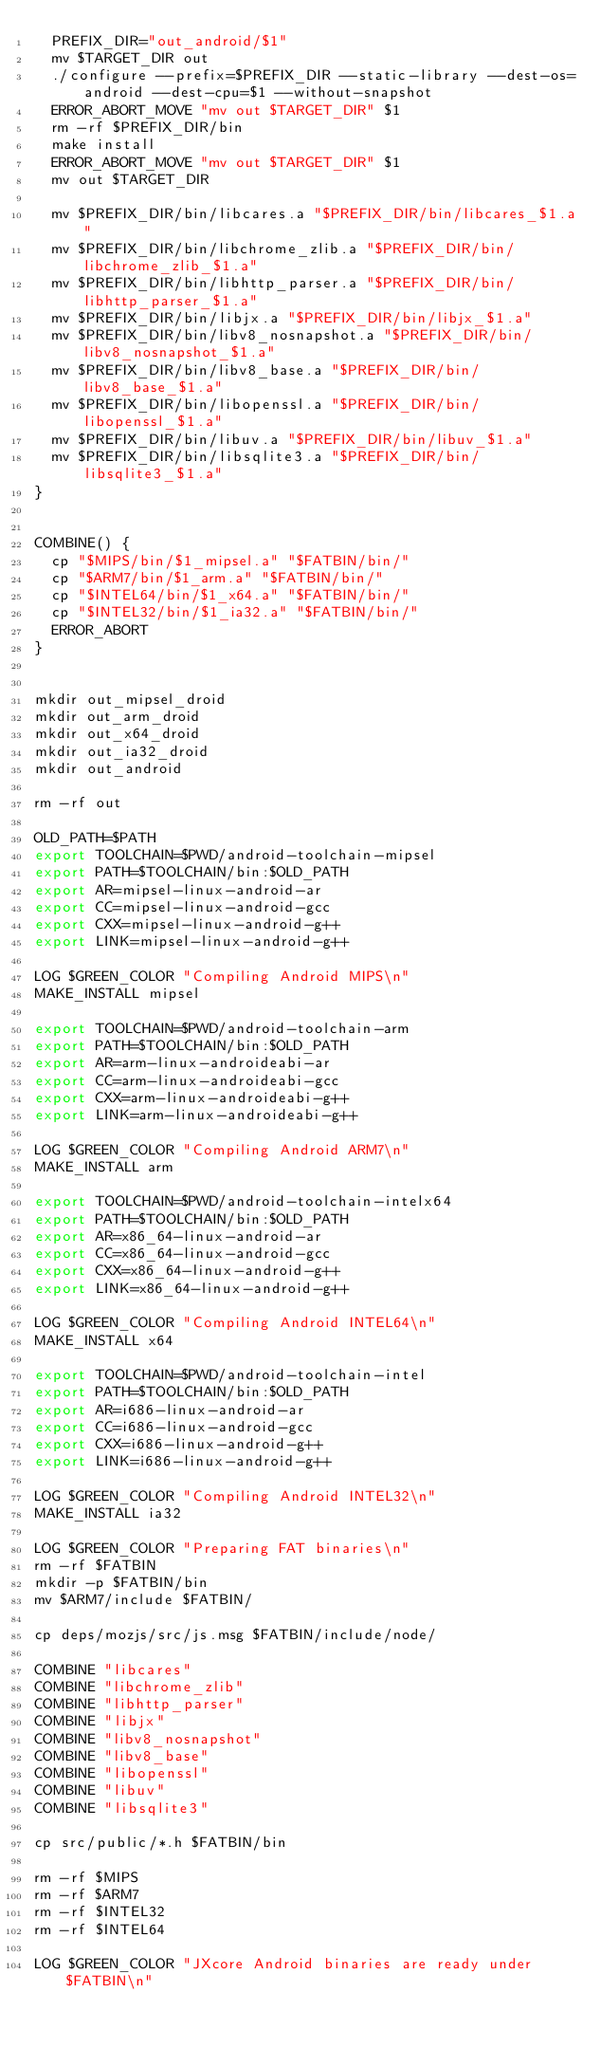Convert code to text. <code><loc_0><loc_0><loc_500><loc_500><_Bash_>  PREFIX_DIR="out_android/$1"
  mv $TARGET_DIR out
  ./configure --prefix=$PREFIX_DIR --static-library --dest-os=android --dest-cpu=$1 --without-snapshot
  ERROR_ABORT_MOVE "mv out $TARGET_DIR" $1
  rm -rf $PREFIX_DIR/bin
  make install
  ERROR_ABORT_MOVE "mv out $TARGET_DIR" $1
  mv out $TARGET_DIR
  
  mv $PREFIX_DIR/bin/libcares.a "$PREFIX_DIR/bin/libcares_$1.a"
  mv $PREFIX_DIR/bin/libchrome_zlib.a "$PREFIX_DIR/bin/libchrome_zlib_$1.a"
  mv $PREFIX_DIR/bin/libhttp_parser.a "$PREFIX_DIR/bin/libhttp_parser_$1.a"
  mv $PREFIX_DIR/bin/libjx.a "$PREFIX_DIR/bin/libjx_$1.a"
  mv $PREFIX_DIR/bin/libv8_nosnapshot.a "$PREFIX_DIR/bin/libv8_nosnapshot_$1.a"
  mv $PREFIX_DIR/bin/libv8_base.a "$PREFIX_DIR/bin/libv8_base_$1.a"
  mv $PREFIX_DIR/bin/libopenssl.a "$PREFIX_DIR/bin/libopenssl_$1.a"
  mv $PREFIX_DIR/bin/libuv.a "$PREFIX_DIR/bin/libuv_$1.a"
  mv $PREFIX_DIR/bin/libsqlite3.a "$PREFIX_DIR/bin/libsqlite3_$1.a"
}


COMBINE() {
  cp "$MIPS/bin/$1_mipsel.a" "$FATBIN/bin/"
  cp "$ARM7/bin/$1_arm.a" "$FATBIN/bin/"
  cp "$INTEL64/bin/$1_x64.a" "$FATBIN/bin/"
  cp "$INTEL32/bin/$1_ia32.a" "$FATBIN/bin/"
  ERROR_ABORT
}


mkdir out_mipsel_droid
mkdir out_arm_droid
mkdir out_x64_droid
mkdir out_ia32_droid
mkdir out_android

rm -rf out

OLD_PATH=$PATH
export TOOLCHAIN=$PWD/android-toolchain-mipsel
export PATH=$TOOLCHAIN/bin:$OLD_PATH
export AR=mipsel-linux-android-ar
export CC=mipsel-linux-android-gcc
export CXX=mipsel-linux-android-g++
export LINK=mipsel-linux-android-g++

LOG $GREEN_COLOR "Compiling Android MIPS\n"
MAKE_INSTALL mipsel

export TOOLCHAIN=$PWD/android-toolchain-arm
export PATH=$TOOLCHAIN/bin:$OLD_PATH
export AR=arm-linux-androideabi-ar
export CC=arm-linux-androideabi-gcc
export CXX=arm-linux-androideabi-g++
export LINK=arm-linux-androideabi-g++

LOG $GREEN_COLOR "Compiling Android ARM7\n"
MAKE_INSTALL arm

export TOOLCHAIN=$PWD/android-toolchain-intelx64
export PATH=$TOOLCHAIN/bin:$OLD_PATH
export AR=x86_64-linux-android-ar
export CC=x86_64-linux-android-gcc
export CXX=x86_64-linux-android-g++
export LINK=x86_64-linux-android-g++

LOG $GREEN_COLOR "Compiling Android INTEL64\n"
MAKE_INSTALL x64

export TOOLCHAIN=$PWD/android-toolchain-intel
export PATH=$TOOLCHAIN/bin:$OLD_PATH
export AR=i686-linux-android-ar
export CC=i686-linux-android-gcc
export CXX=i686-linux-android-g++
export LINK=i686-linux-android-g++

LOG $GREEN_COLOR "Compiling Android INTEL32\n"
MAKE_INSTALL ia32

LOG $GREEN_COLOR "Preparing FAT binaries\n"
rm -rf $FATBIN
mkdir -p $FATBIN/bin
mv $ARM7/include $FATBIN/

cp deps/mozjs/src/js.msg $FATBIN/include/node/

COMBINE "libcares"
COMBINE "libchrome_zlib"
COMBINE "libhttp_parser"
COMBINE "libjx"
COMBINE "libv8_nosnapshot"
COMBINE "libv8_base"
COMBINE "libopenssl"
COMBINE "libuv"
COMBINE "libsqlite3"

cp src/public/*.h $FATBIN/bin

rm -rf $MIPS
rm -rf $ARM7
rm -rf $INTEL32
rm -rf $INTEL64

LOG $GREEN_COLOR "JXcore Android binaries are ready under $FATBIN\n"</code> 